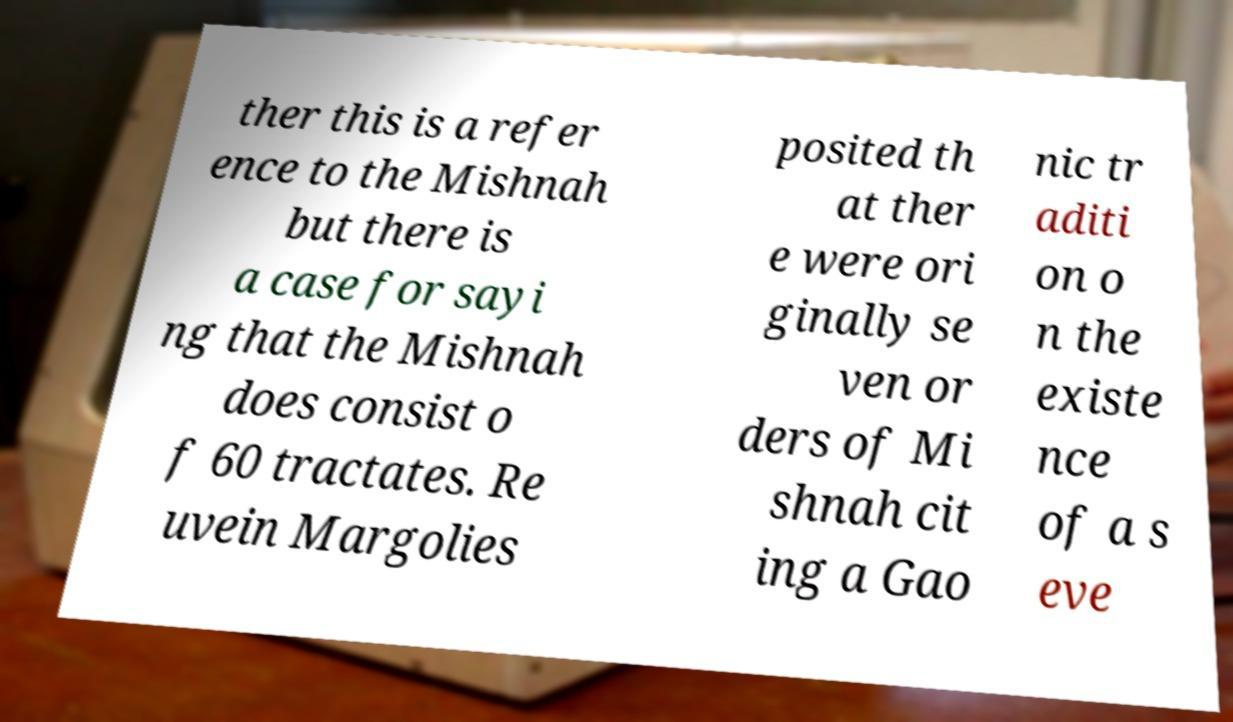Can you accurately transcribe the text from the provided image for me? ther this is a refer ence to the Mishnah but there is a case for sayi ng that the Mishnah does consist o f 60 tractates. Re uvein Margolies posited th at ther e were ori ginally se ven or ders of Mi shnah cit ing a Gao nic tr aditi on o n the existe nce of a s eve 